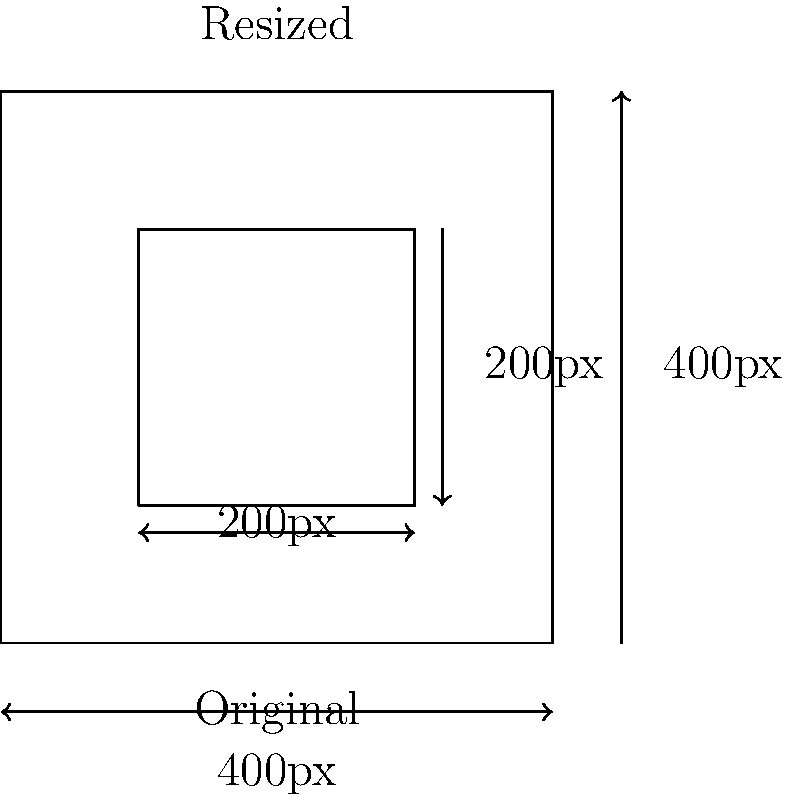A WordPress theme requires featured images for posts to be 200x200 pixels. You have a square image that is 400x400 pixels. What scale factor should you use to resize the image to fit the required dimensions for the featured image in the post layout? To determine the scale factor for resizing the image, we need to follow these steps:

1. Identify the original dimensions:
   Original width = 400 pixels
   Original height = 400 pixels

2. Identify the target dimensions:
   Target width = 200 pixels
   Target height = 200 pixels

3. Calculate the scale factor:
   The scale factor is the ratio of the target dimension to the original dimension.
   Since the image is square, we can use either width or height for this calculation.

   Scale factor = Target dimension ÷ Original dimension
   
   $$\text{Scale factor} = \frac{\text{Target width}}{\text{Original width}} = \frac{200 \text{ pixels}}{400 \text{ pixels}} = \frac{1}{2} = 0.5$$

4. Verify the result:
   New width = Original width × Scale factor = 400 × 0.5 = 200 pixels
   New height = Original height × Scale factor = 400 × 0.5 = 200 pixels

The scale factor of 0.5 will resize the 400x400 pixel image to 200x200 pixels, fitting the required dimensions for the featured image in the post layout.
Answer: 0.5 